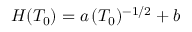<formula> <loc_0><loc_0><loc_500><loc_500>H ( T _ { 0 } ) = a \, ( T _ { 0 } ) ^ { - 1 / 2 } + b</formula> 